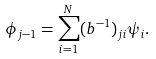<formula> <loc_0><loc_0><loc_500><loc_500>\phi _ { j - 1 } = \sum _ { i = 1 } ^ { N } ( b ^ { - 1 } ) _ { j i } \psi _ { i } .</formula> 